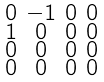Convert formula to latex. <formula><loc_0><loc_0><loc_500><loc_500>\begin{smallmatrix} 0 & - 1 & 0 & 0 \\ 1 & 0 & 0 & 0 \\ 0 & 0 & 0 & 0 \\ 0 & 0 & 0 & 0 \end{smallmatrix}</formula> 